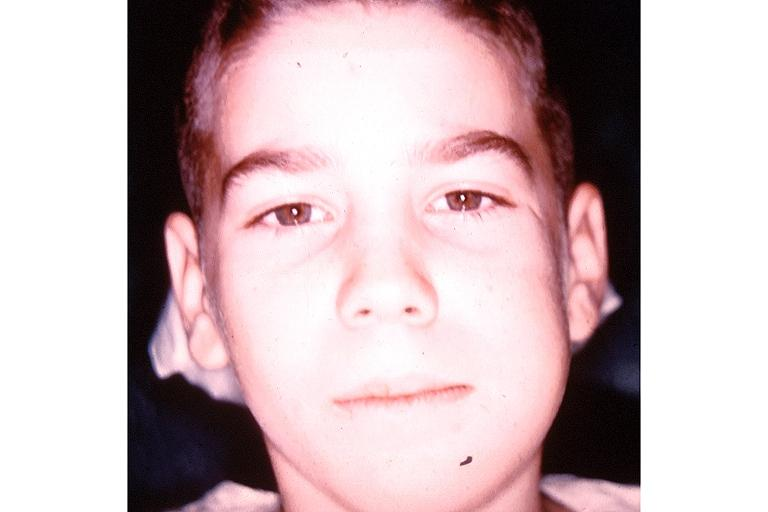s oral present?
Answer the question using a single word or phrase. Yes 